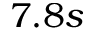<formula> <loc_0><loc_0><loc_500><loc_500>7 . 8 s</formula> 